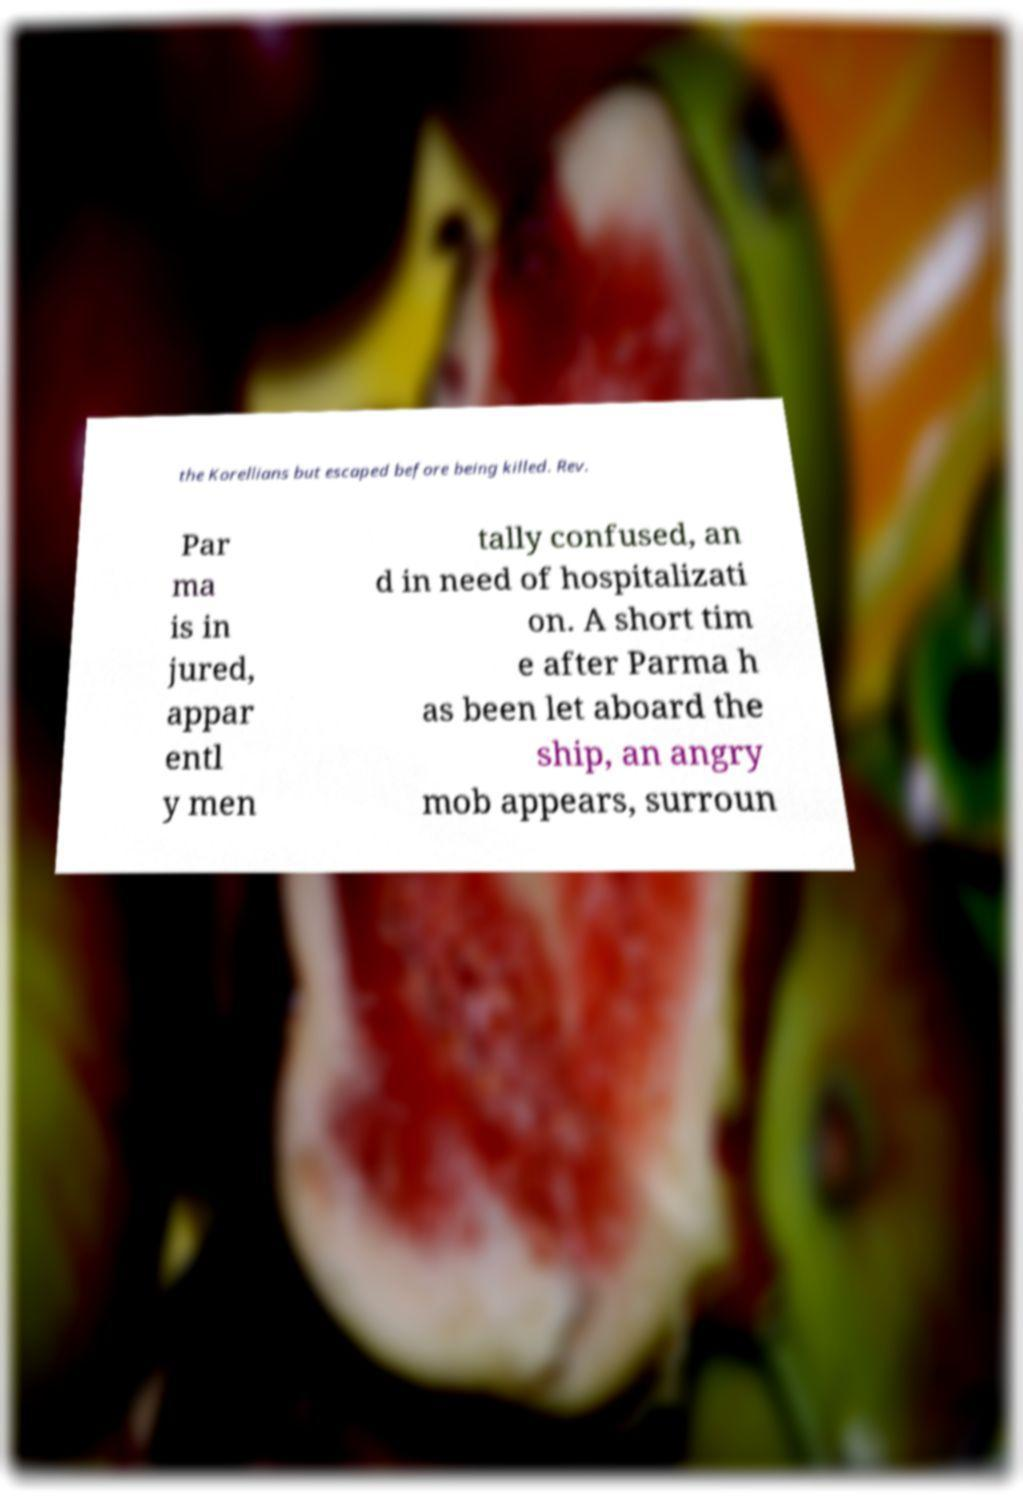For documentation purposes, I need the text within this image transcribed. Could you provide that? the Korellians but escaped before being killed. Rev. Par ma is in jured, appar entl y men tally confused, an d in need of hospitalizati on. A short tim e after Parma h as been let aboard the ship, an angry mob appears, surroun 